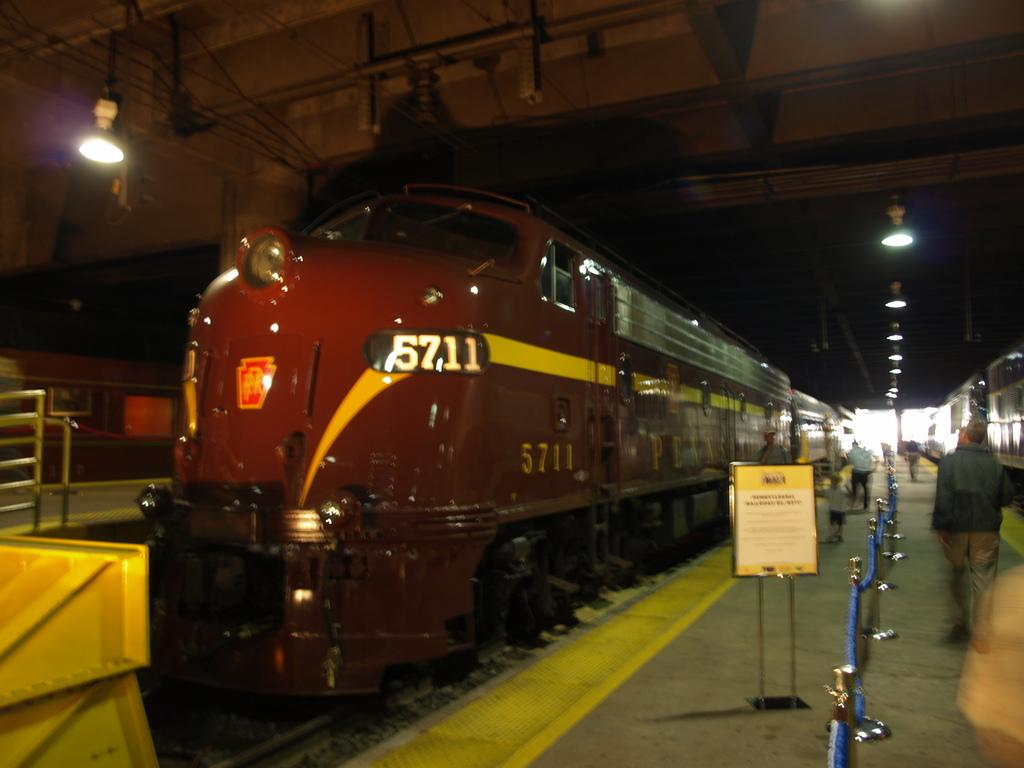What is the main subject of the image? The main subject of the image is a train on the track. What else can be seen in the image besides the train? There is an advertisement board and light visible in the image. Are there any people in the image? Yes, people are walking in the image. What type of vest is the train wearing in the image? Trains do not wear vests; the question is not applicable to the image. 